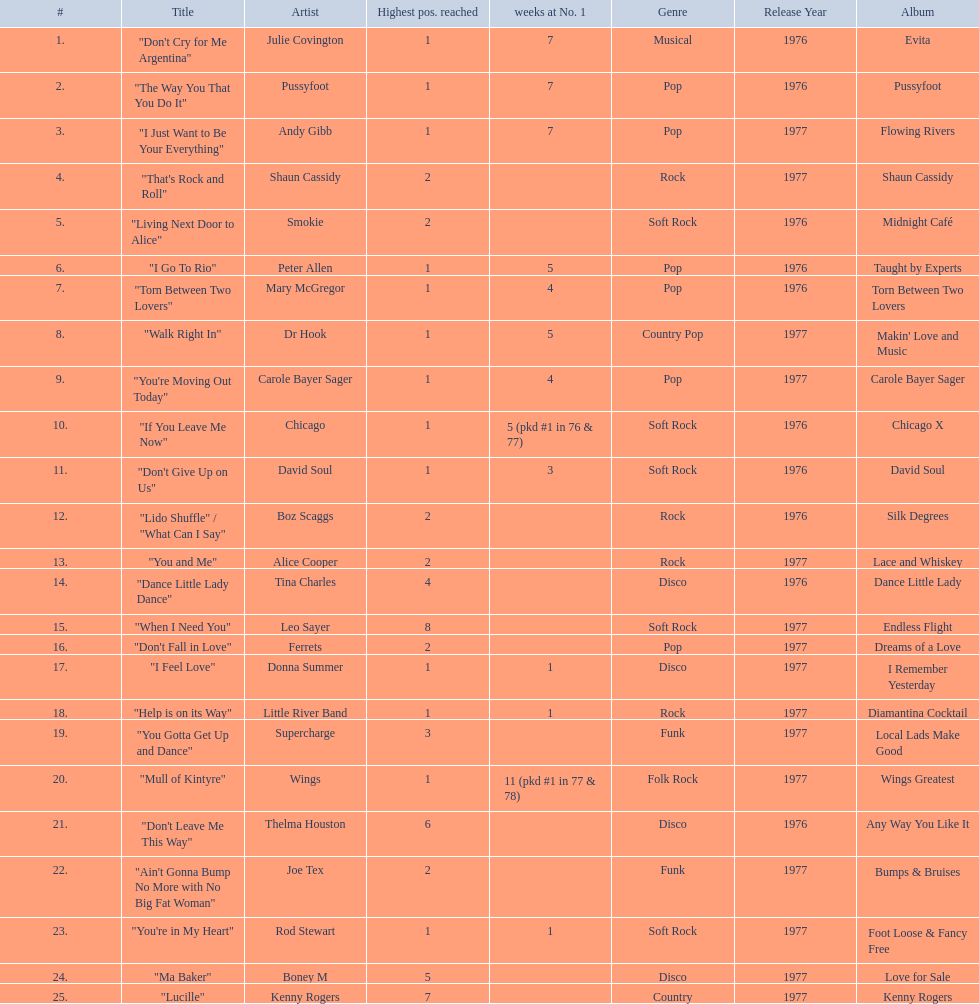Who had the one of the least weeks at number one? Rod Stewart. Would you be able to parse every entry in this table? {'header': ['#', 'Title', 'Artist', 'Highest pos. reached', 'weeks at No. 1', 'Genre', 'Release Year', 'Album'], 'rows': [['1.', '"Don\'t Cry for Me Argentina"', 'Julie Covington', '1', '7', 'Musical', '1976', 'Evita'], ['2.', '"The Way You That You Do It"', 'Pussyfoot', '1', '7', 'Pop', '1976', 'Pussyfoot'], ['3.', '"I Just Want to Be Your Everything"', 'Andy Gibb', '1', '7', 'Pop', '1977', 'Flowing Rivers'], ['4.', '"That\'s Rock and Roll"', 'Shaun Cassidy', '2', '', 'Rock', '1977', 'Shaun Cassidy'], ['5.', '"Living Next Door to Alice"', 'Smokie', '2', '', 'Soft Rock', '1976', 'Midnight Café'], ['6.', '"I Go To Rio"', 'Peter Allen', '1', '5', 'Pop', '1976', 'Taught by Experts'], ['7.', '"Torn Between Two Lovers"', 'Mary McGregor', '1', '4', 'Pop', '1976', 'Torn Between Two Lovers'], ['8.', '"Walk Right In"', 'Dr Hook', '1', '5', 'Country Pop', '1977', "Makin' Love and Music"], ['9.', '"You\'re Moving Out Today"', 'Carole Bayer Sager', '1', '4', 'Pop', '1977', 'Carole Bayer Sager'], ['10.', '"If You Leave Me Now"', 'Chicago', '1', '5 (pkd #1 in 76 & 77)', 'Soft Rock', '1976', 'Chicago X'], ['11.', '"Don\'t Give Up on Us"', 'David Soul', '1', '3', 'Soft Rock', '1976', 'David Soul'], ['12.', '"Lido Shuffle" / "What Can I Say"', 'Boz Scaggs', '2', '', 'Rock', '1976', 'Silk Degrees'], ['13.', '"You and Me"', 'Alice Cooper', '2', '', 'Rock', '1977', 'Lace and Whiskey'], ['14.', '"Dance Little Lady Dance"', 'Tina Charles', '4', '', 'Disco', '1976', 'Dance Little Lady'], ['15.', '"When I Need You"', 'Leo Sayer', '8', '', 'Soft Rock', '1977', 'Endless Flight'], ['16.', '"Don\'t Fall in Love"', 'Ferrets', '2', '', 'Pop', '1977', 'Dreams of a Love'], ['17.', '"I Feel Love"', 'Donna Summer', '1', '1', 'Disco', '1977', 'I Remember Yesterday'], ['18.', '"Help is on its Way"', 'Little River Band', '1', '1', 'Rock', '1977', 'Diamantina Cocktail'], ['19.', '"You Gotta Get Up and Dance"', 'Supercharge', '3', '', 'Funk', '1977', 'Local Lads Make Good'], ['20.', '"Mull of Kintyre"', 'Wings', '1', '11 (pkd #1 in 77 & 78)', 'Folk Rock', '1977', 'Wings Greatest'], ['21.', '"Don\'t Leave Me This Way"', 'Thelma Houston', '6', '', 'Disco', '1976', 'Any Way You Like It'], ['22.', '"Ain\'t Gonna Bump No More with No Big Fat Woman"', 'Joe Tex', '2', '', 'Funk', '1977', 'Bumps & Bruises'], ['23.', '"You\'re in My Heart"', 'Rod Stewart', '1', '1', 'Soft Rock', '1977', 'Foot Loose & Fancy Free'], ['24.', '"Ma Baker"', 'Boney M', '5', '', 'Disco', '1977', 'Love for Sale'], ['25.', '"Lucille"', 'Kenny Rogers', '7', '', 'Country', '1977', 'Kenny Rogers']]} Who had no week at number one? Shaun Cassidy. Who had the highest number of weeks at number one? Wings. 